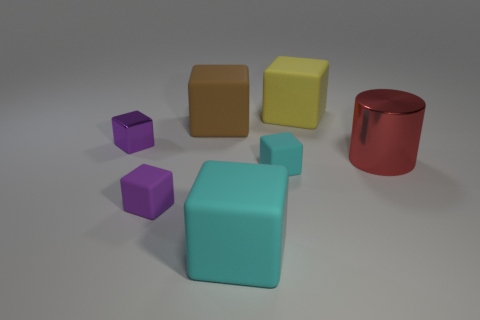The metal object in front of the shiny object behind the metallic cylinder is what shape?
Provide a succinct answer. Cylinder. Are there any big red objects that have the same material as the large brown thing?
Your response must be concise. No. There is another cube that is the same color as the metallic cube; what is its size?
Your response must be concise. Small. What number of red objects are big blocks or spheres?
Offer a very short reply. 0. Are there any objects that have the same color as the metal cube?
Ensure brevity in your answer.  Yes. What size is the object that is the same material as the cylinder?
Give a very brief answer. Small. What number of blocks are either tiny yellow objects or big red metallic objects?
Ensure brevity in your answer.  0. Is the number of red metallic spheres greater than the number of large blocks?
Make the answer very short. No. What number of purple rubber blocks have the same size as the brown cube?
Your answer should be compact. 0. There is another thing that is the same color as the small metal thing; what is its shape?
Provide a short and direct response. Cube. 